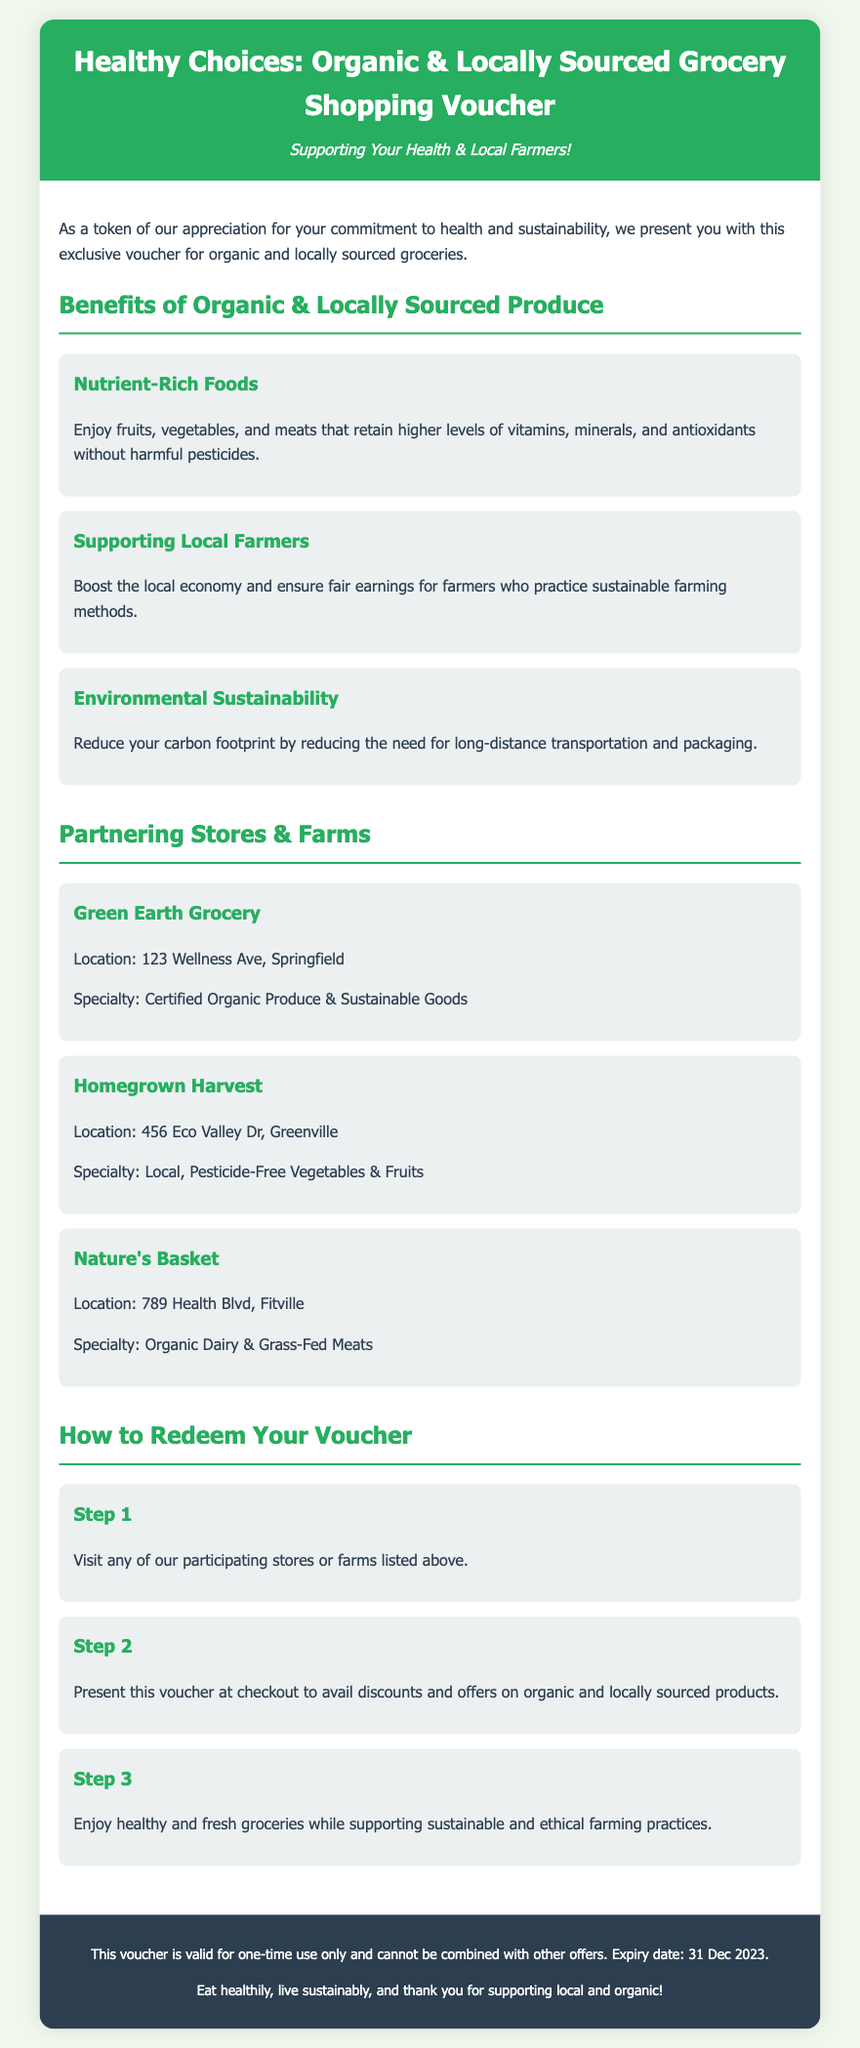What is the title of the voucher? The title is prominently displayed at the top of the document, clearly stating the purpose of the voucher.
Answer: Healthy Choices: Organic & Locally Sourced Grocery Shopping Voucher What is the location of Green Earth Grocery? This information is provided next to the store name in the partner section, which shows various participating stores.
Answer: 123 Wellness Ave, Springfield What is the expiry date of the voucher? The expiry date is mentioned in the footer of the document, indicating the deadline for voucher usage.
Answer: 31 Dec 2023 How many steps are there to redeem the voucher? The steps to redeem the voucher are outlined in a separate section, asking users to take notice of the process.
Answer: 3 What benefit is associated with supporting local farmers? One of the benefits highlights the impact of local farmers on the community and economic practices.
Answer: Boost the local economy and ensure fair earnings What type of produce is emphasized in the organic benefits? The document highlights specific types of food to emphasize health benefits associated with organic farming.
Answer: Fruits, vegetables, and meats What is the specialty of Homegrown Harvest? Details about the stores also include their specialties, providing insight into their offerings.
Answer: Local, Pesticide-Free Vegetables & Fruits What color is used for the header of the voucher? The background color for the header is an important design aspect, adding to the document's appeal.
Answer: Green 